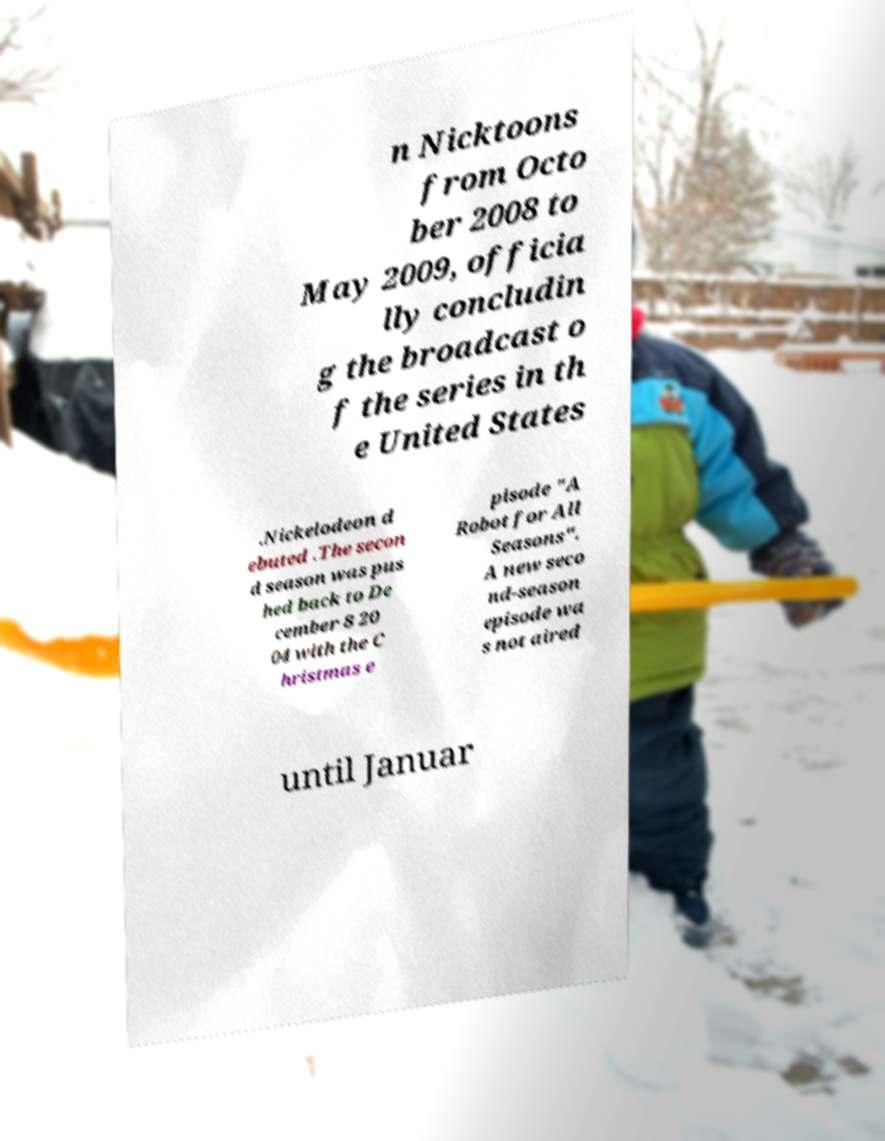Could you assist in decoding the text presented in this image and type it out clearly? n Nicktoons from Octo ber 2008 to May 2009, officia lly concludin g the broadcast o f the series in th e United States .Nickelodeon d ebuted .The secon d season was pus hed back to De cember 8 20 04 with the C hristmas e pisode "A Robot for All Seasons". A new seco nd-season episode wa s not aired until Januar 